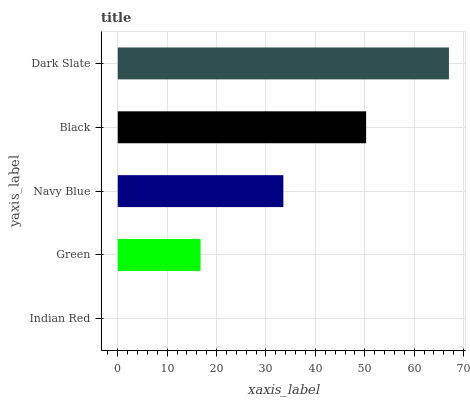Is Indian Red the minimum?
Answer yes or no. Yes. Is Dark Slate the maximum?
Answer yes or no. Yes. Is Green the minimum?
Answer yes or no. No. Is Green the maximum?
Answer yes or no. No. Is Green greater than Indian Red?
Answer yes or no. Yes. Is Indian Red less than Green?
Answer yes or no. Yes. Is Indian Red greater than Green?
Answer yes or no. No. Is Green less than Indian Red?
Answer yes or no. No. Is Navy Blue the high median?
Answer yes or no. Yes. Is Navy Blue the low median?
Answer yes or no. Yes. Is Black the high median?
Answer yes or no. No. Is Green the low median?
Answer yes or no. No. 